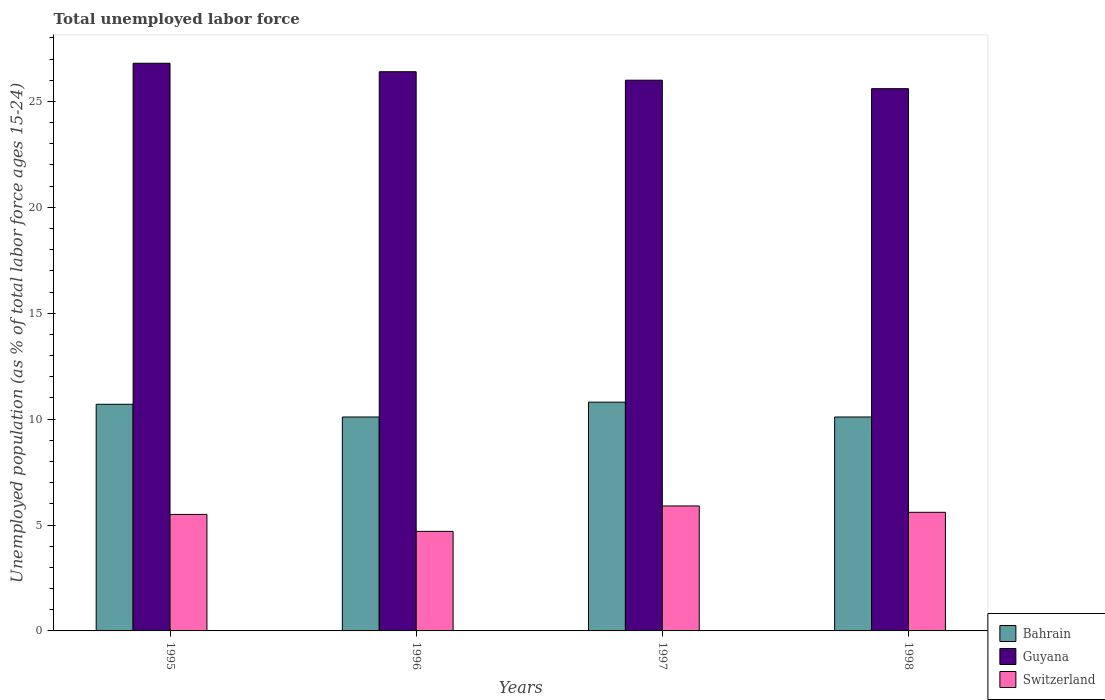How many different coloured bars are there?
Provide a short and direct response. 3. Are the number of bars on each tick of the X-axis equal?
Ensure brevity in your answer.  Yes. In how many cases, is the number of bars for a given year not equal to the number of legend labels?
Give a very brief answer. 0. Across all years, what is the maximum percentage of unemployed population in in Bahrain?
Make the answer very short. 10.8. Across all years, what is the minimum percentage of unemployed population in in Switzerland?
Your answer should be very brief. 4.7. In which year was the percentage of unemployed population in in Switzerland maximum?
Provide a short and direct response. 1997. What is the total percentage of unemployed population in in Switzerland in the graph?
Your answer should be compact. 21.7. What is the difference between the percentage of unemployed population in in Bahrain in 1995 and that in 1996?
Offer a terse response. 0.6. What is the difference between the percentage of unemployed population in in Bahrain in 1998 and the percentage of unemployed population in in Switzerland in 1995?
Your answer should be compact. 4.6. What is the average percentage of unemployed population in in Guyana per year?
Provide a succinct answer. 26.2. In the year 1995, what is the difference between the percentage of unemployed population in in Switzerland and percentage of unemployed population in in Guyana?
Make the answer very short. -21.3. In how many years, is the percentage of unemployed population in in Guyana greater than 10 %?
Ensure brevity in your answer.  4. What is the ratio of the percentage of unemployed population in in Switzerland in 1996 to that in 1998?
Provide a succinct answer. 0.84. Is the percentage of unemployed population in in Bahrain in 1996 less than that in 1997?
Keep it short and to the point. Yes. Is the difference between the percentage of unemployed population in in Switzerland in 1997 and 1998 greater than the difference between the percentage of unemployed population in in Guyana in 1997 and 1998?
Your response must be concise. No. What is the difference between the highest and the second highest percentage of unemployed population in in Bahrain?
Your answer should be compact. 0.1. What is the difference between the highest and the lowest percentage of unemployed population in in Switzerland?
Offer a terse response. 1.2. What does the 3rd bar from the left in 1995 represents?
Provide a succinct answer. Switzerland. What does the 2nd bar from the right in 1997 represents?
Keep it short and to the point. Guyana. How many bars are there?
Your response must be concise. 12. What is the difference between two consecutive major ticks on the Y-axis?
Offer a very short reply. 5. Are the values on the major ticks of Y-axis written in scientific E-notation?
Provide a succinct answer. No. Does the graph contain grids?
Provide a succinct answer. No. Where does the legend appear in the graph?
Provide a short and direct response. Bottom right. How are the legend labels stacked?
Provide a succinct answer. Vertical. What is the title of the graph?
Provide a short and direct response. Total unemployed labor force. Does "Uganda" appear as one of the legend labels in the graph?
Your answer should be very brief. No. What is the label or title of the Y-axis?
Offer a very short reply. Unemployed population (as % of total labor force ages 15-24). What is the Unemployed population (as % of total labor force ages 15-24) of Bahrain in 1995?
Provide a succinct answer. 10.7. What is the Unemployed population (as % of total labor force ages 15-24) in Guyana in 1995?
Your answer should be compact. 26.8. What is the Unemployed population (as % of total labor force ages 15-24) in Switzerland in 1995?
Make the answer very short. 5.5. What is the Unemployed population (as % of total labor force ages 15-24) of Bahrain in 1996?
Your response must be concise. 10.1. What is the Unemployed population (as % of total labor force ages 15-24) of Guyana in 1996?
Ensure brevity in your answer.  26.4. What is the Unemployed population (as % of total labor force ages 15-24) of Switzerland in 1996?
Offer a terse response. 4.7. What is the Unemployed population (as % of total labor force ages 15-24) of Bahrain in 1997?
Give a very brief answer. 10.8. What is the Unemployed population (as % of total labor force ages 15-24) of Guyana in 1997?
Ensure brevity in your answer.  26. What is the Unemployed population (as % of total labor force ages 15-24) in Switzerland in 1997?
Provide a succinct answer. 5.9. What is the Unemployed population (as % of total labor force ages 15-24) of Bahrain in 1998?
Offer a terse response. 10.1. What is the Unemployed population (as % of total labor force ages 15-24) of Guyana in 1998?
Make the answer very short. 25.6. What is the Unemployed population (as % of total labor force ages 15-24) in Switzerland in 1998?
Provide a succinct answer. 5.6. Across all years, what is the maximum Unemployed population (as % of total labor force ages 15-24) in Bahrain?
Make the answer very short. 10.8. Across all years, what is the maximum Unemployed population (as % of total labor force ages 15-24) of Guyana?
Keep it short and to the point. 26.8. Across all years, what is the maximum Unemployed population (as % of total labor force ages 15-24) in Switzerland?
Provide a succinct answer. 5.9. Across all years, what is the minimum Unemployed population (as % of total labor force ages 15-24) in Bahrain?
Keep it short and to the point. 10.1. Across all years, what is the minimum Unemployed population (as % of total labor force ages 15-24) in Guyana?
Ensure brevity in your answer.  25.6. Across all years, what is the minimum Unemployed population (as % of total labor force ages 15-24) of Switzerland?
Offer a very short reply. 4.7. What is the total Unemployed population (as % of total labor force ages 15-24) in Bahrain in the graph?
Your response must be concise. 41.7. What is the total Unemployed population (as % of total labor force ages 15-24) of Guyana in the graph?
Your answer should be very brief. 104.8. What is the total Unemployed population (as % of total labor force ages 15-24) of Switzerland in the graph?
Provide a succinct answer. 21.7. What is the difference between the Unemployed population (as % of total labor force ages 15-24) in Switzerland in 1995 and that in 1996?
Provide a short and direct response. 0.8. What is the difference between the Unemployed population (as % of total labor force ages 15-24) in Guyana in 1995 and that in 1997?
Ensure brevity in your answer.  0.8. What is the difference between the Unemployed population (as % of total labor force ages 15-24) of Guyana in 1996 and that in 1997?
Provide a succinct answer. 0.4. What is the difference between the Unemployed population (as % of total labor force ages 15-24) of Switzerland in 1996 and that in 1997?
Provide a succinct answer. -1.2. What is the difference between the Unemployed population (as % of total labor force ages 15-24) of Bahrain in 1997 and that in 1998?
Your response must be concise. 0.7. What is the difference between the Unemployed population (as % of total labor force ages 15-24) of Switzerland in 1997 and that in 1998?
Keep it short and to the point. 0.3. What is the difference between the Unemployed population (as % of total labor force ages 15-24) of Bahrain in 1995 and the Unemployed population (as % of total labor force ages 15-24) of Guyana in 1996?
Your answer should be compact. -15.7. What is the difference between the Unemployed population (as % of total labor force ages 15-24) of Guyana in 1995 and the Unemployed population (as % of total labor force ages 15-24) of Switzerland in 1996?
Provide a short and direct response. 22.1. What is the difference between the Unemployed population (as % of total labor force ages 15-24) of Bahrain in 1995 and the Unemployed population (as % of total labor force ages 15-24) of Guyana in 1997?
Your answer should be very brief. -15.3. What is the difference between the Unemployed population (as % of total labor force ages 15-24) of Bahrain in 1995 and the Unemployed population (as % of total labor force ages 15-24) of Switzerland in 1997?
Keep it short and to the point. 4.8. What is the difference between the Unemployed population (as % of total labor force ages 15-24) of Guyana in 1995 and the Unemployed population (as % of total labor force ages 15-24) of Switzerland in 1997?
Provide a short and direct response. 20.9. What is the difference between the Unemployed population (as % of total labor force ages 15-24) of Bahrain in 1995 and the Unemployed population (as % of total labor force ages 15-24) of Guyana in 1998?
Your answer should be very brief. -14.9. What is the difference between the Unemployed population (as % of total labor force ages 15-24) in Bahrain in 1995 and the Unemployed population (as % of total labor force ages 15-24) in Switzerland in 1998?
Give a very brief answer. 5.1. What is the difference between the Unemployed population (as % of total labor force ages 15-24) of Guyana in 1995 and the Unemployed population (as % of total labor force ages 15-24) of Switzerland in 1998?
Your response must be concise. 21.2. What is the difference between the Unemployed population (as % of total labor force ages 15-24) of Bahrain in 1996 and the Unemployed population (as % of total labor force ages 15-24) of Guyana in 1997?
Make the answer very short. -15.9. What is the difference between the Unemployed population (as % of total labor force ages 15-24) of Bahrain in 1996 and the Unemployed population (as % of total labor force ages 15-24) of Switzerland in 1997?
Offer a terse response. 4.2. What is the difference between the Unemployed population (as % of total labor force ages 15-24) of Guyana in 1996 and the Unemployed population (as % of total labor force ages 15-24) of Switzerland in 1997?
Keep it short and to the point. 20.5. What is the difference between the Unemployed population (as % of total labor force ages 15-24) in Bahrain in 1996 and the Unemployed population (as % of total labor force ages 15-24) in Guyana in 1998?
Keep it short and to the point. -15.5. What is the difference between the Unemployed population (as % of total labor force ages 15-24) of Guyana in 1996 and the Unemployed population (as % of total labor force ages 15-24) of Switzerland in 1998?
Make the answer very short. 20.8. What is the difference between the Unemployed population (as % of total labor force ages 15-24) of Bahrain in 1997 and the Unemployed population (as % of total labor force ages 15-24) of Guyana in 1998?
Your response must be concise. -14.8. What is the difference between the Unemployed population (as % of total labor force ages 15-24) of Bahrain in 1997 and the Unemployed population (as % of total labor force ages 15-24) of Switzerland in 1998?
Ensure brevity in your answer.  5.2. What is the difference between the Unemployed population (as % of total labor force ages 15-24) in Guyana in 1997 and the Unemployed population (as % of total labor force ages 15-24) in Switzerland in 1998?
Provide a short and direct response. 20.4. What is the average Unemployed population (as % of total labor force ages 15-24) of Bahrain per year?
Ensure brevity in your answer.  10.43. What is the average Unemployed population (as % of total labor force ages 15-24) of Guyana per year?
Make the answer very short. 26.2. What is the average Unemployed population (as % of total labor force ages 15-24) of Switzerland per year?
Keep it short and to the point. 5.42. In the year 1995, what is the difference between the Unemployed population (as % of total labor force ages 15-24) of Bahrain and Unemployed population (as % of total labor force ages 15-24) of Guyana?
Provide a succinct answer. -16.1. In the year 1995, what is the difference between the Unemployed population (as % of total labor force ages 15-24) in Guyana and Unemployed population (as % of total labor force ages 15-24) in Switzerland?
Your response must be concise. 21.3. In the year 1996, what is the difference between the Unemployed population (as % of total labor force ages 15-24) of Bahrain and Unemployed population (as % of total labor force ages 15-24) of Guyana?
Offer a very short reply. -16.3. In the year 1996, what is the difference between the Unemployed population (as % of total labor force ages 15-24) of Guyana and Unemployed population (as % of total labor force ages 15-24) of Switzerland?
Keep it short and to the point. 21.7. In the year 1997, what is the difference between the Unemployed population (as % of total labor force ages 15-24) in Bahrain and Unemployed population (as % of total labor force ages 15-24) in Guyana?
Your response must be concise. -15.2. In the year 1997, what is the difference between the Unemployed population (as % of total labor force ages 15-24) in Bahrain and Unemployed population (as % of total labor force ages 15-24) in Switzerland?
Keep it short and to the point. 4.9. In the year 1997, what is the difference between the Unemployed population (as % of total labor force ages 15-24) in Guyana and Unemployed population (as % of total labor force ages 15-24) in Switzerland?
Your answer should be very brief. 20.1. In the year 1998, what is the difference between the Unemployed population (as % of total labor force ages 15-24) in Bahrain and Unemployed population (as % of total labor force ages 15-24) in Guyana?
Make the answer very short. -15.5. In the year 1998, what is the difference between the Unemployed population (as % of total labor force ages 15-24) in Bahrain and Unemployed population (as % of total labor force ages 15-24) in Switzerland?
Offer a very short reply. 4.5. In the year 1998, what is the difference between the Unemployed population (as % of total labor force ages 15-24) of Guyana and Unemployed population (as % of total labor force ages 15-24) of Switzerland?
Your response must be concise. 20. What is the ratio of the Unemployed population (as % of total labor force ages 15-24) of Bahrain in 1995 to that in 1996?
Your answer should be very brief. 1.06. What is the ratio of the Unemployed population (as % of total labor force ages 15-24) of Guyana in 1995 to that in 1996?
Give a very brief answer. 1.02. What is the ratio of the Unemployed population (as % of total labor force ages 15-24) in Switzerland in 1995 to that in 1996?
Keep it short and to the point. 1.17. What is the ratio of the Unemployed population (as % of total labor force ages 15-24) of Bahrain in 1995 to that in 1997?
Offer a very short reply. 0.99. What is the ratio of the Unemployed population (as % of total labor force ages 15-24) in Guyana in 1995 to that in 1997?
Your response must be concise. 1.03. What is the ratio of the Unemployed population (as % of total labor force ages 15-24) in Switzerland in 1995 to that in 1997?
Provide a succinct answer. 0.93. What is the ratio of the Unemployed population (as % of total labor force ages 15-24) in Bahrain in 1995 to that in 1998?
Give a very brief answer. 1.06. What is the ratio of the Unemployed population (as % of total labor force ages 15-24) in Guyana in 1995 to that in 1998?
Make the answer very short. 1.05. What is the ratio of the Unemployed population (as % of total labor force ages 15-24) in Switzerland in 1995 to that in 1998?
Keep it short and to the point. 0.98. What is the ratio of the Unemployed population (as % of total labor force ages 15-24) in Bahrain in 1996 to that in 1997?
Ensure brevity in your answer.  0.94. What is the ratio of the Unemployed population (as % of total labor force ages 15-24) of Guyana in 1996 to that in 1997?
Keep it short and to the point. 1.02. What is the ratio of the Unemployed population (as % of total labor force ages 15-24) in Switzerland in 1996 to that in 1997?
Keep it short and to the point. 0.8. What is the ratio of the Unemployed population (as % of total labor force ages 15-24) of Bahrain in 1996 to that in 1998?
Offer a terse response. 1. What is the ratio of the Unemployed population (as % of total labor force ages 15-24) in Guyana in 1996 to that in 1998?
Offer a terse response. 1.03. What is the ratio of the Unemployed population (as % of total labor force ages 15-24) of Switzerland in 1996 to that in 1998?
Make the answer very short. 0.84. What is the ratio of the Unemployed population (as % of total labor force ages 15-24) in Bahrain in 1997 to that in 1998?
Keep it short and to the point. 1.07. What is the ratio of the Unemployed population (as % of total labor force ages 15-24) of Guyana in 1997 to that in 1998?
Offer a very short reply. 1.02. What is the ratio of the Unemployed population (as % of total labor force ages 15-24) of Switzerland in 1997 to that in 1998?
Make the answer very short. 1.05. What is the difference between the highest and the second highest Unemployed population (as % of total labor force ages 15-24) of Bahrain?
Provide a succinct answer. 0.1. What is the difference between the highest and the second highest Unemployed population (as % of total labor force ages 15-24) of Guyana?
Ensure brevity in your answer.  0.4. What is the difference between the highest and the second highest Unemployed population (as % of total labor force ages 15-24) in Switzerland?
Your response must be concise. 0.3. What is the difference between the highest and the lowest Unemployed population (as % of total labor force ages 15-24) in Bahrain?
Provide a short and direct response. 0.7. 